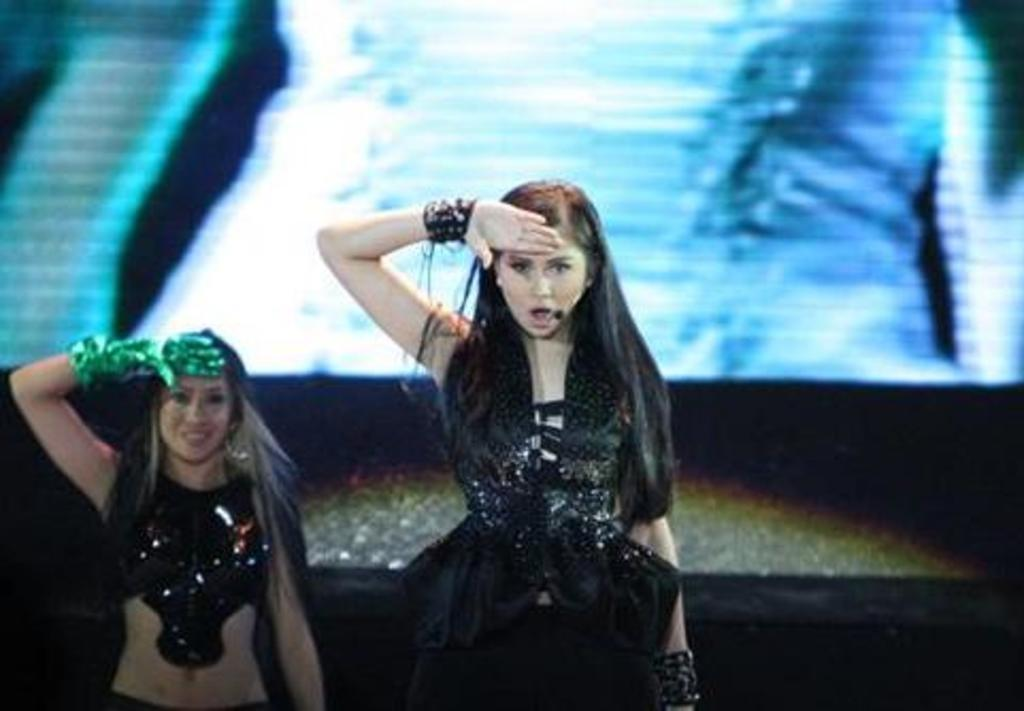How many people are present in the image? There are two girls in the image. What can be seen in the background of the image? There is a screen visible in the background of the image. What suggestion does the night offer in the image? There is no mention of night or any suggestion in the image; it only features two girls and a screen in the background. 